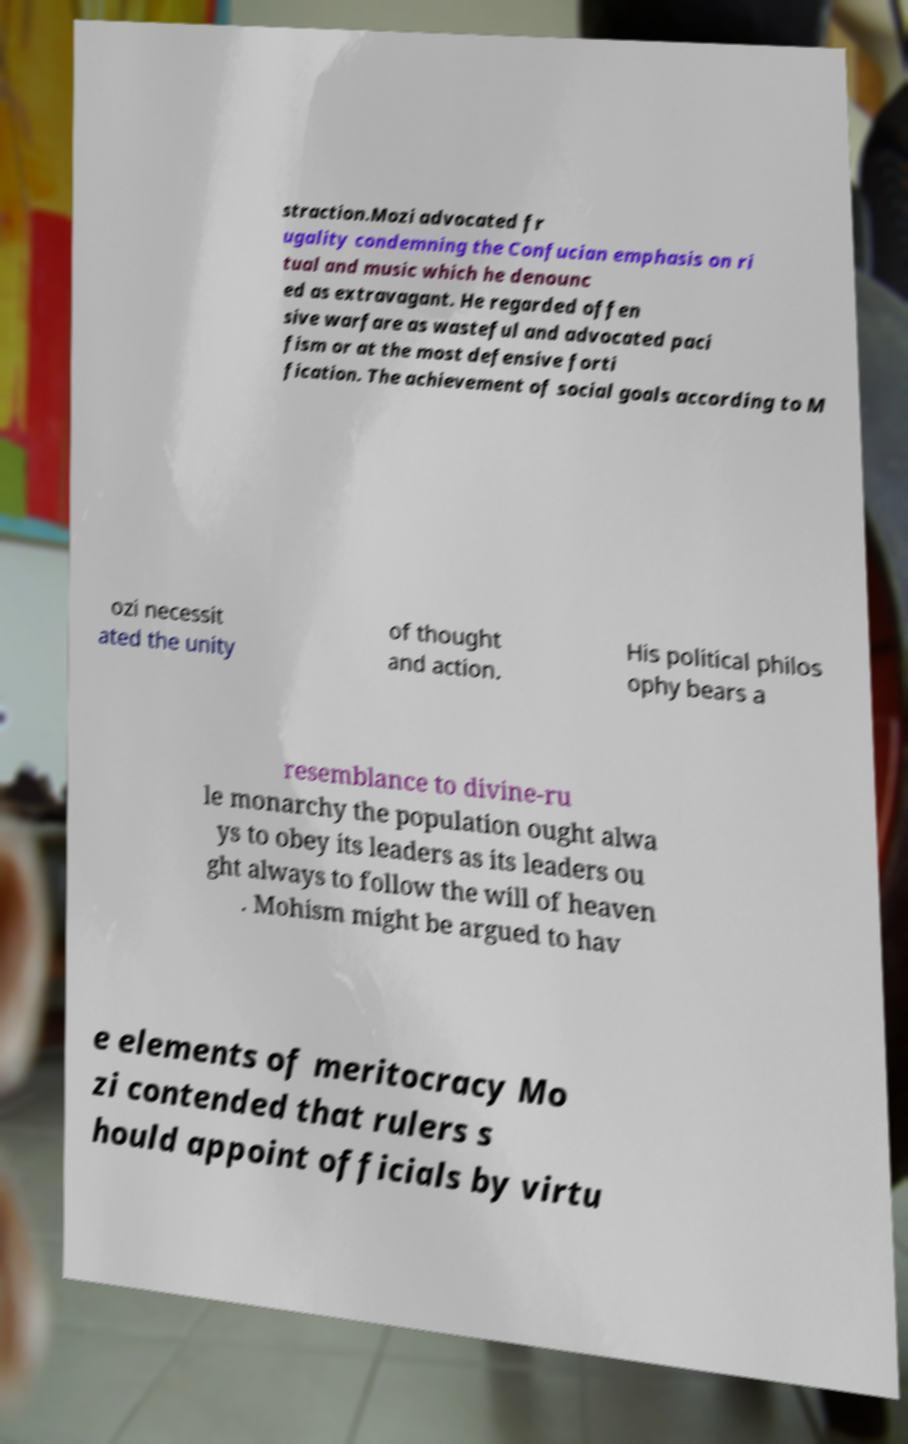Please read and relay the text visible in this image. What does it say? straction.Mozi advocated fr ugality condemning the Confucian emphasis on ri tual and music which he denounc ed as extravagant. He regarded offen sive warfare as wasteful and advocated paci fism or at the most defensive forti fication. The achievement of social goals according to M ozi necessit ated the unity of thought and action. His political philos ophy bears a resemblance to divine-ru le monarchy the population ought alwa ys to obey its leaders as its leaders ou ght always to follow the will of heaven . Mohism might be argued to hav e elements of meritocracy Mo zi contended that rulers s hould appoint officials by virtu 